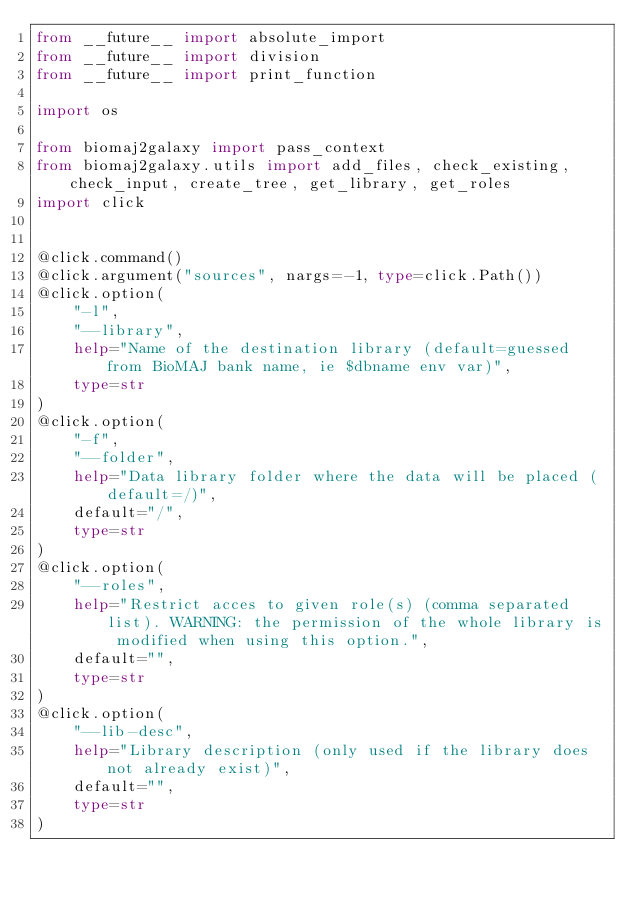Convert code to text. <code><loc_0><loc_0><loc_500><loc_500><_Python_>from __future__ import absolute_import
from __future__ import division
from __future__ import print_function

import os

from biomaj2galaxy import pass_context
from biomaj2galaxy.utils import add_files, check_existing, check_input, create_tree, get_library, get_roles
import click


@click.command()
@click.argument("sources", nargs=-1, type=click.Path())
@click.option(
    "-l",
    "--library",
    help="Name of the destination library (default=guessed from BioMAJ bank name, ie $dbname env var)",
    type=str
)
@click.option(
    "-f",
    "--folder",
    help="Data library folder where the data will be placed (default=/)",
    default="/",
    type=str
)
@click.option(
    "--roles",
    help="Restrict acces to given role(s) (comma separated list). WARNING: the permission of the whole library is modified when using this option.",
    default="",
    type=str
)
@click.option(
    "--lib-desc",
    help="Library description (only used if the library does not already exist)",
    default="",
    type=str
)</code> 